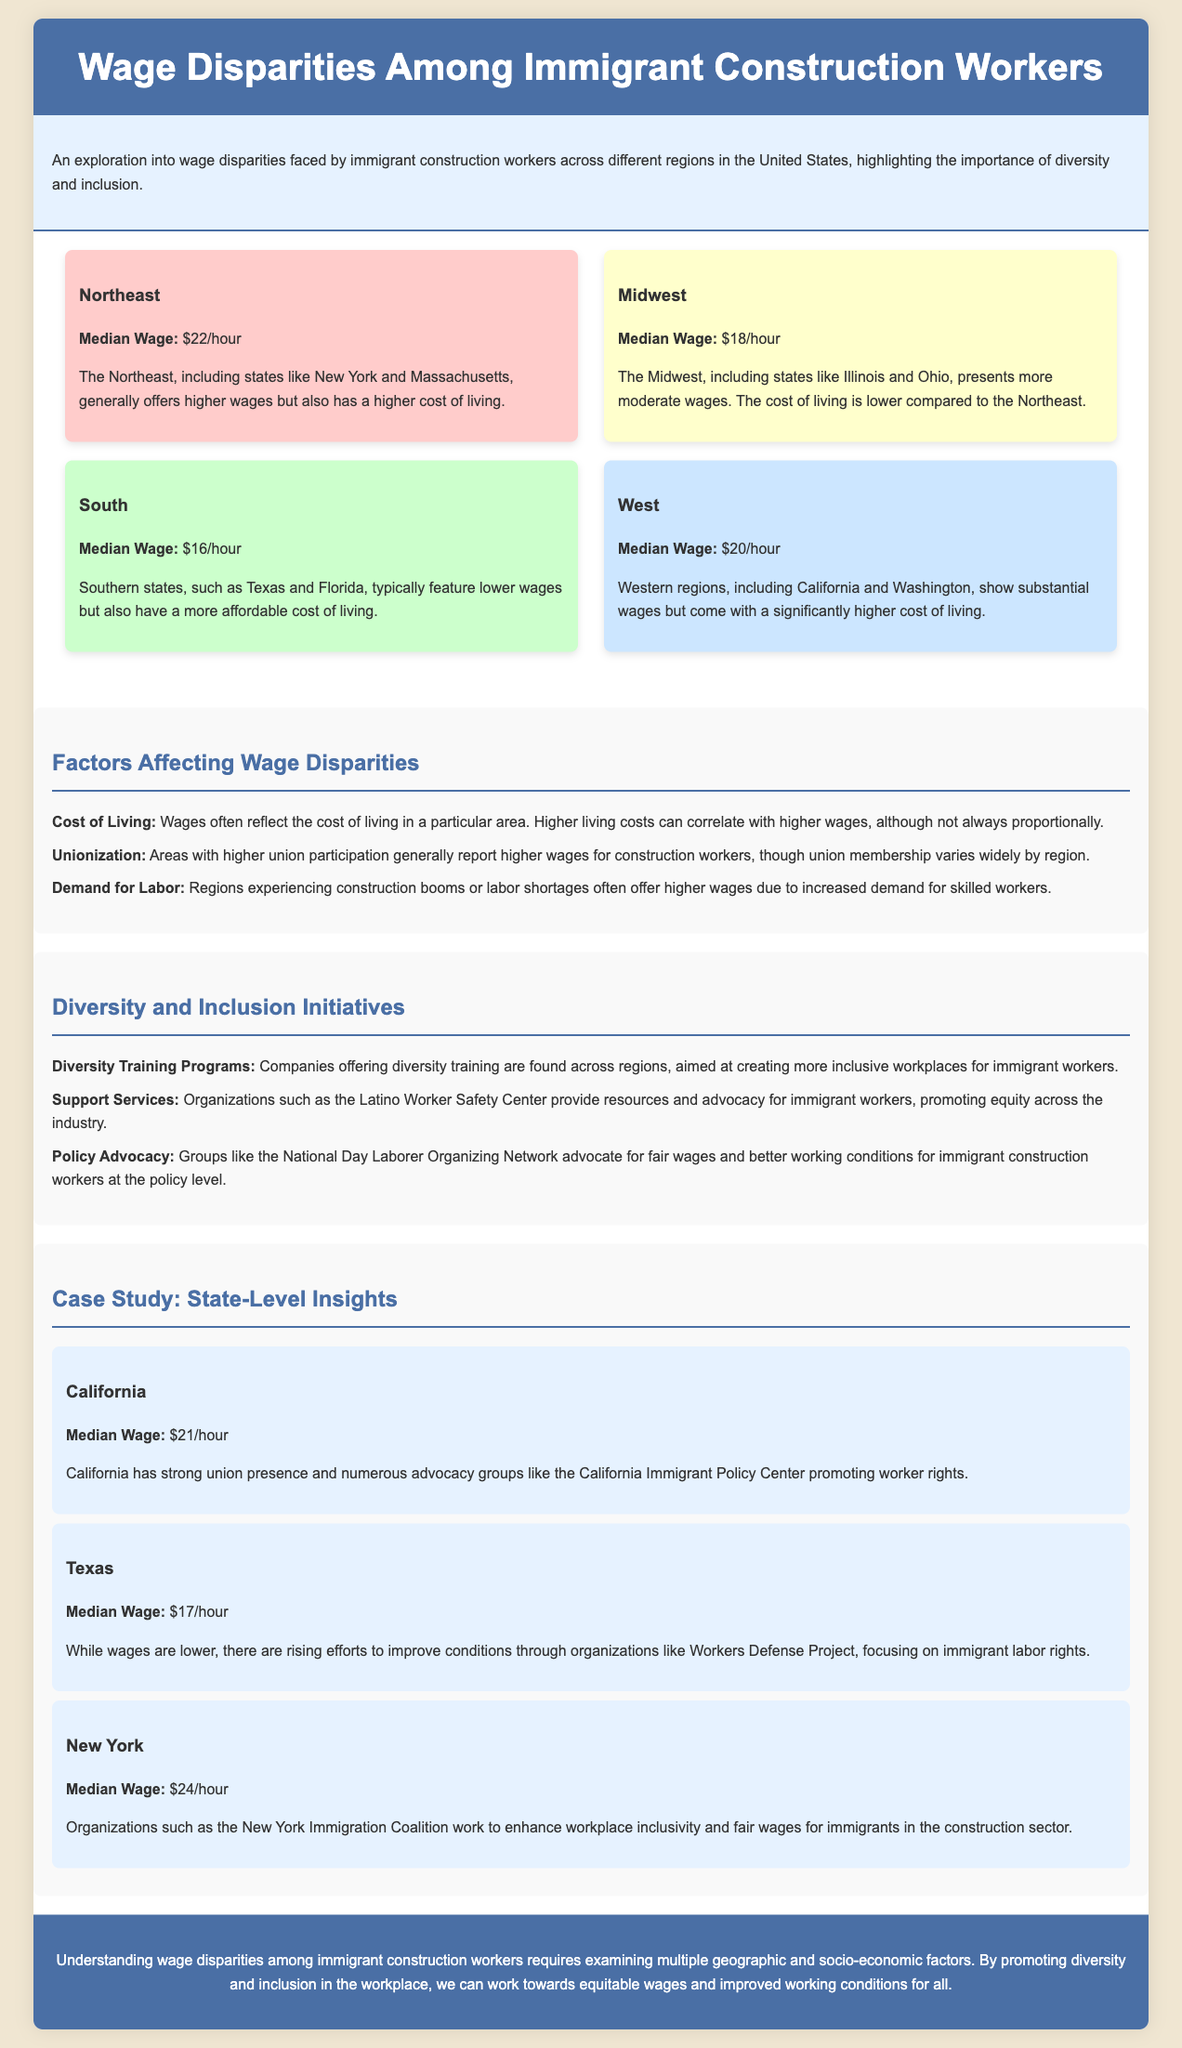What is the median wage in the Northeast region? The median wage in the Northeast region is stated as $22/hour in the document.
Answer: $22/hour Which state is included in the Midwest region? The document mentions Illinois and Ohio as part of the Midwest region.
Answer: Illinois What is one factor affecting wage disparities? The document lists cost of living, unionization, and demand for labor as factors affecting wage disparities.
Answer: Cost of Living What organization advocates for better working conditions in Texas? The document states that the Workers Defense Project focuses on improving conditions for immigrant labor in Texas.
Answer: Workers Defense Project What is the median wage in California according to the case study? The document indicates that the median wage in California is $21/hour.
Answer: $21/hour Which region has the highest median wage? The Northeast region is noted for having the highest median wage among the regions mentioned.
Answer: Northeast In what type of programs do companies offer diversity training? The document discusses diversity training programs aimed at fostering inclusivity among immigrant workers.
Answer: Diversity Training Programs What does the case study mention about New York? The case study highlights that organizations in New York work to enhance workplace inclusivity and fair wages for immigrants.
Answer: New York Immigration Coalition What is identified as a common characteristic in areas with higher wages? The document notes that higher union participation typically correlates with increased wages for construction workers.
Answer: Unionization 